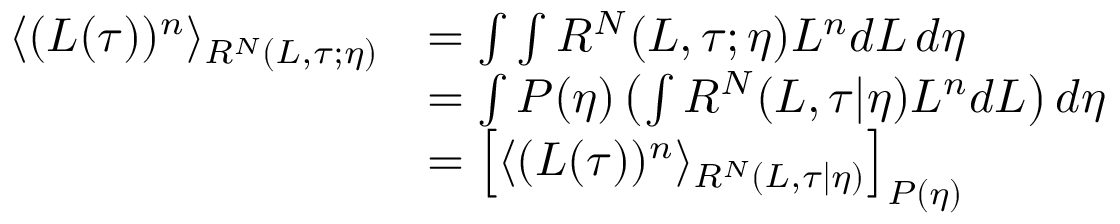<formula> <loc_0><loc_0><loc_500><loc_500>\begin{array} { r l } { \langle ( L ( \tau ) ) ^ { n } \rangle _ { R ^ { N } ( L , \tau ; \eta ) } } & { = \int \int R ^ { N } ( L , \tau ; \eta ) L ^ { n } d L \, d \eta } \\ & { = \int P ( \eta ) \left ( \int R ^ { N } ( L , \tau | \eta ) L ^ { n } d L \right ) d \eta } \\ & { = \left [ \langle ( L ( \tau ) ) ^ { n } \rangle _ { R ^ { N } ( L , \tau | \eta ) } \right ] _ { P ( \eta ) } } \end{array}</formula> 